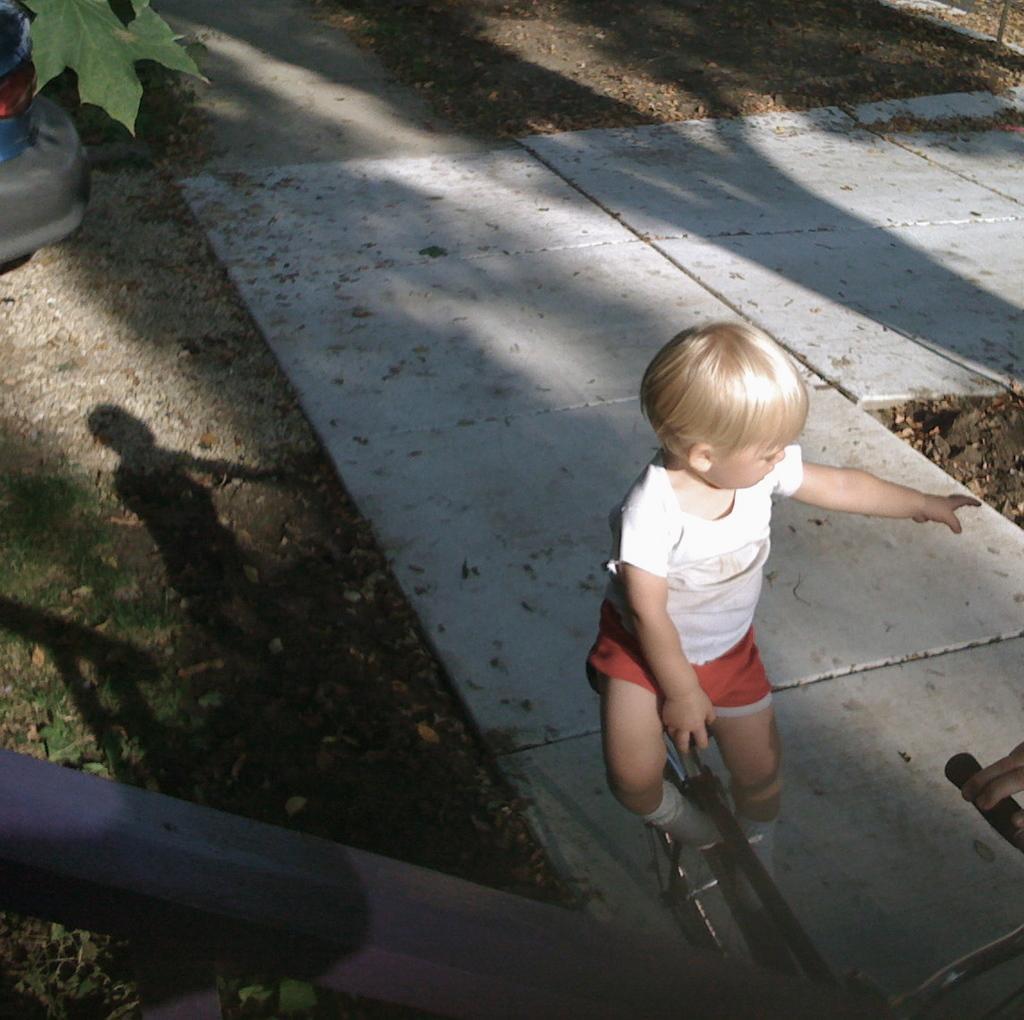Describe this image in one or two sentences. On the right side of the image we can see a kid sitting on the bicycle. At the bottom there is a fence. In the background we can see a walkway. 